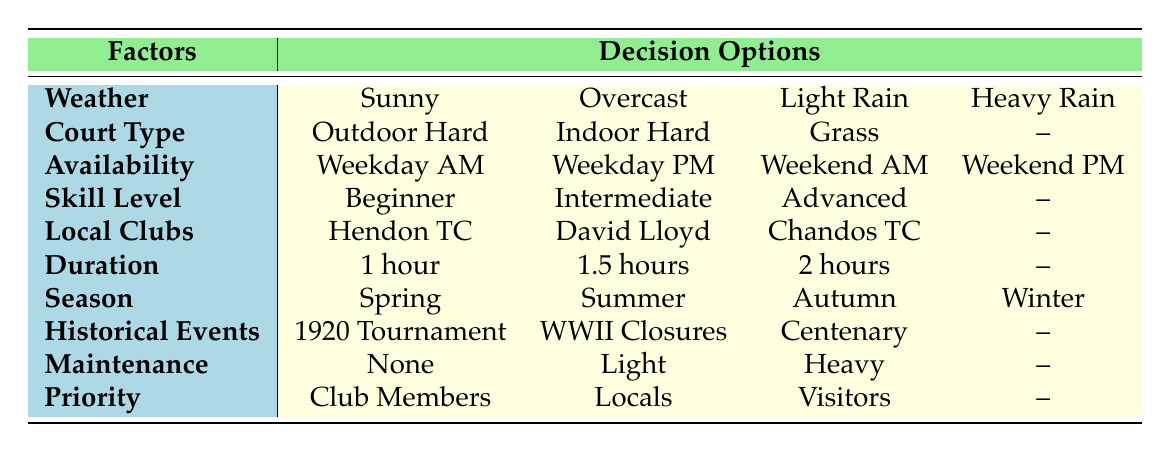What court type is available for light rain weather? According to the table, for light rain weather, the available court type is "Indoor Hard" because outdoor options would not be suitable under such conditions.
Answer: Indoor Hard Can a beginner book a court for a weekday morning? Yes, a beginner can book a court for a weekday morning, as there is an option for "Beginner" in skill level and "Weekday Mornings" in availability.
Answer: Yes What is the maximum booking duration listed? The maximum booking duration listed is 2 hours. The durations available are 1 hour, 1.5 hours, and 2 hours.
Answer: 2 hours Is there a court available for weekend afternoons during heavy maintenance? No, the table does not specify any court type available during heavy maintenance for weekend afternoons; it simply lists heavy maintenance without an applicable court type during that time.
Answer: No How many seasonal options are listed in the table? The table has four seasonal options: Spring, Summer, Autumn, and Winter. Therefore, the total count is four.
Answer: 4 If a player prefers to book at "David Lloyd Finchley" during the summer, what skill levels can they choose from? The table lists three skill levels: Beginner, Intermediate, and Advanced as available options regardless of the venue. Therefore, all skill levels can be chosen.
Answer: Beginner, Intermediate, Advanced Which maintenance option is available when booking during the Hendon Tennis Tournament 1920? The table does not specify a maintenance option for the historical events, so we can assume that the available options would still include "No Maintenance," "Light Maintenance," or "Heavy Maintenance." Therefore, "No Maintenance" is a typical choice during such events.
Answer: No Maintenance Can visitors book the grass court during overcast weather? The grass court option is not specified under "Overcast" conditions; referring to the information provided, we cannot conclusively say that grass courts are available during this weather.
Answer: Unknown 